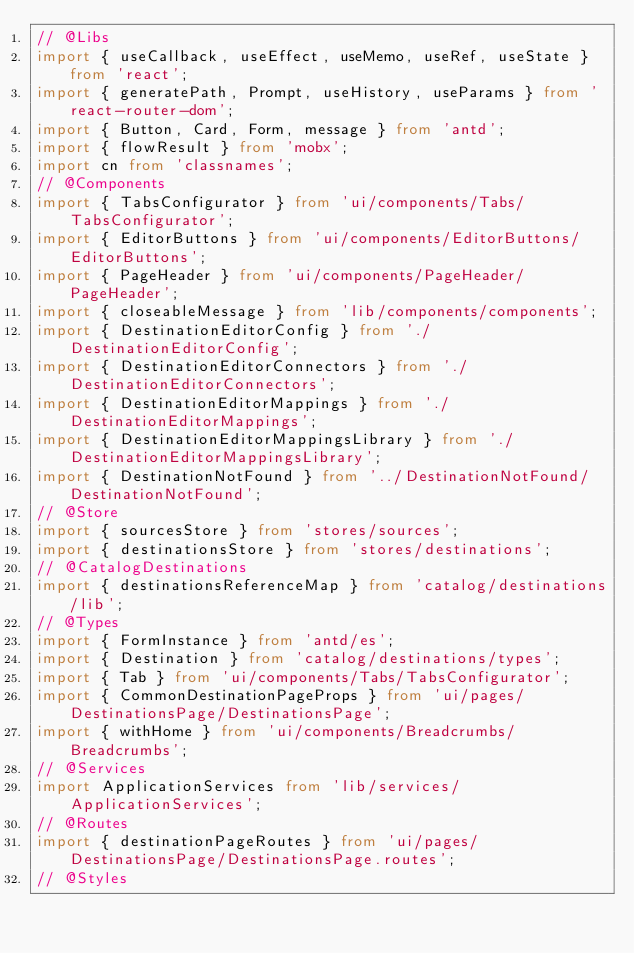Convert code to text. <code><loc_0><loc_0><loc_500><loc_500><_TypeScript_>// @Libs
import { useCallback, useEffect, useMemo, useRef, useState } from 'react';
import { generatePath, Prompt, useHistory, useParams } from 'react-router-dom';
import { Button, Card, Form, message } from 'antd';
import { flowResult } from 'mobx';
import cn from 'classnames';
// @Components
import { TabsConfigurator } from 'ui/components/Tabs/TabsConfigurator';
import { EditorButtons } from 'ui/components/EditorButtons/EditorButtons';
import { PageHeader } from 'ui/components/PageHeader/PageHeader';
import { closeableMessage } from 'lib/components/components';
import { DestinationEditorConfig } from './DestinationEditorConfig';
import { DestinationEditorConnectors } from './DestinationEditorConnectors';
import { DestinationEditorMappings } from './DestinationEditorMappings';
import { DestinationEditorMappingsLibrary } from './DestinationEditorMappingsLibrary';
import { DestinationNotFound } from '../DestinationNotFound/DestinationNotFound';
// @Store
import { sourcesStore } from 'stores/sources';
import { destinationsStore } from 'stores/destinations';
// @CatalogDestinations
import { destinationsReferenceMap } from 'catalog/destinations/lib';
// @Types
import { FormInstance } from 'antd/es';
import { Destination } from 'catalog/destinations/types';
import { Tab } from 'ui/components/Tabs/TabsConfigurator';
import { CommonDestinationPageProps } from 'ui/pages/DestinationsPage/DestinationsPage';
import { withHome } from 'ui/components/Breadcrumbs/Breadcrumbs';
// @Services
import ApplicationServices from 'lib/services/ApplicationServices';
// @Routes
import { destinationPageRoutes } from 'ui/pages/DestinationsPage/DestinationsPage.routes';
// @Styles</code> 